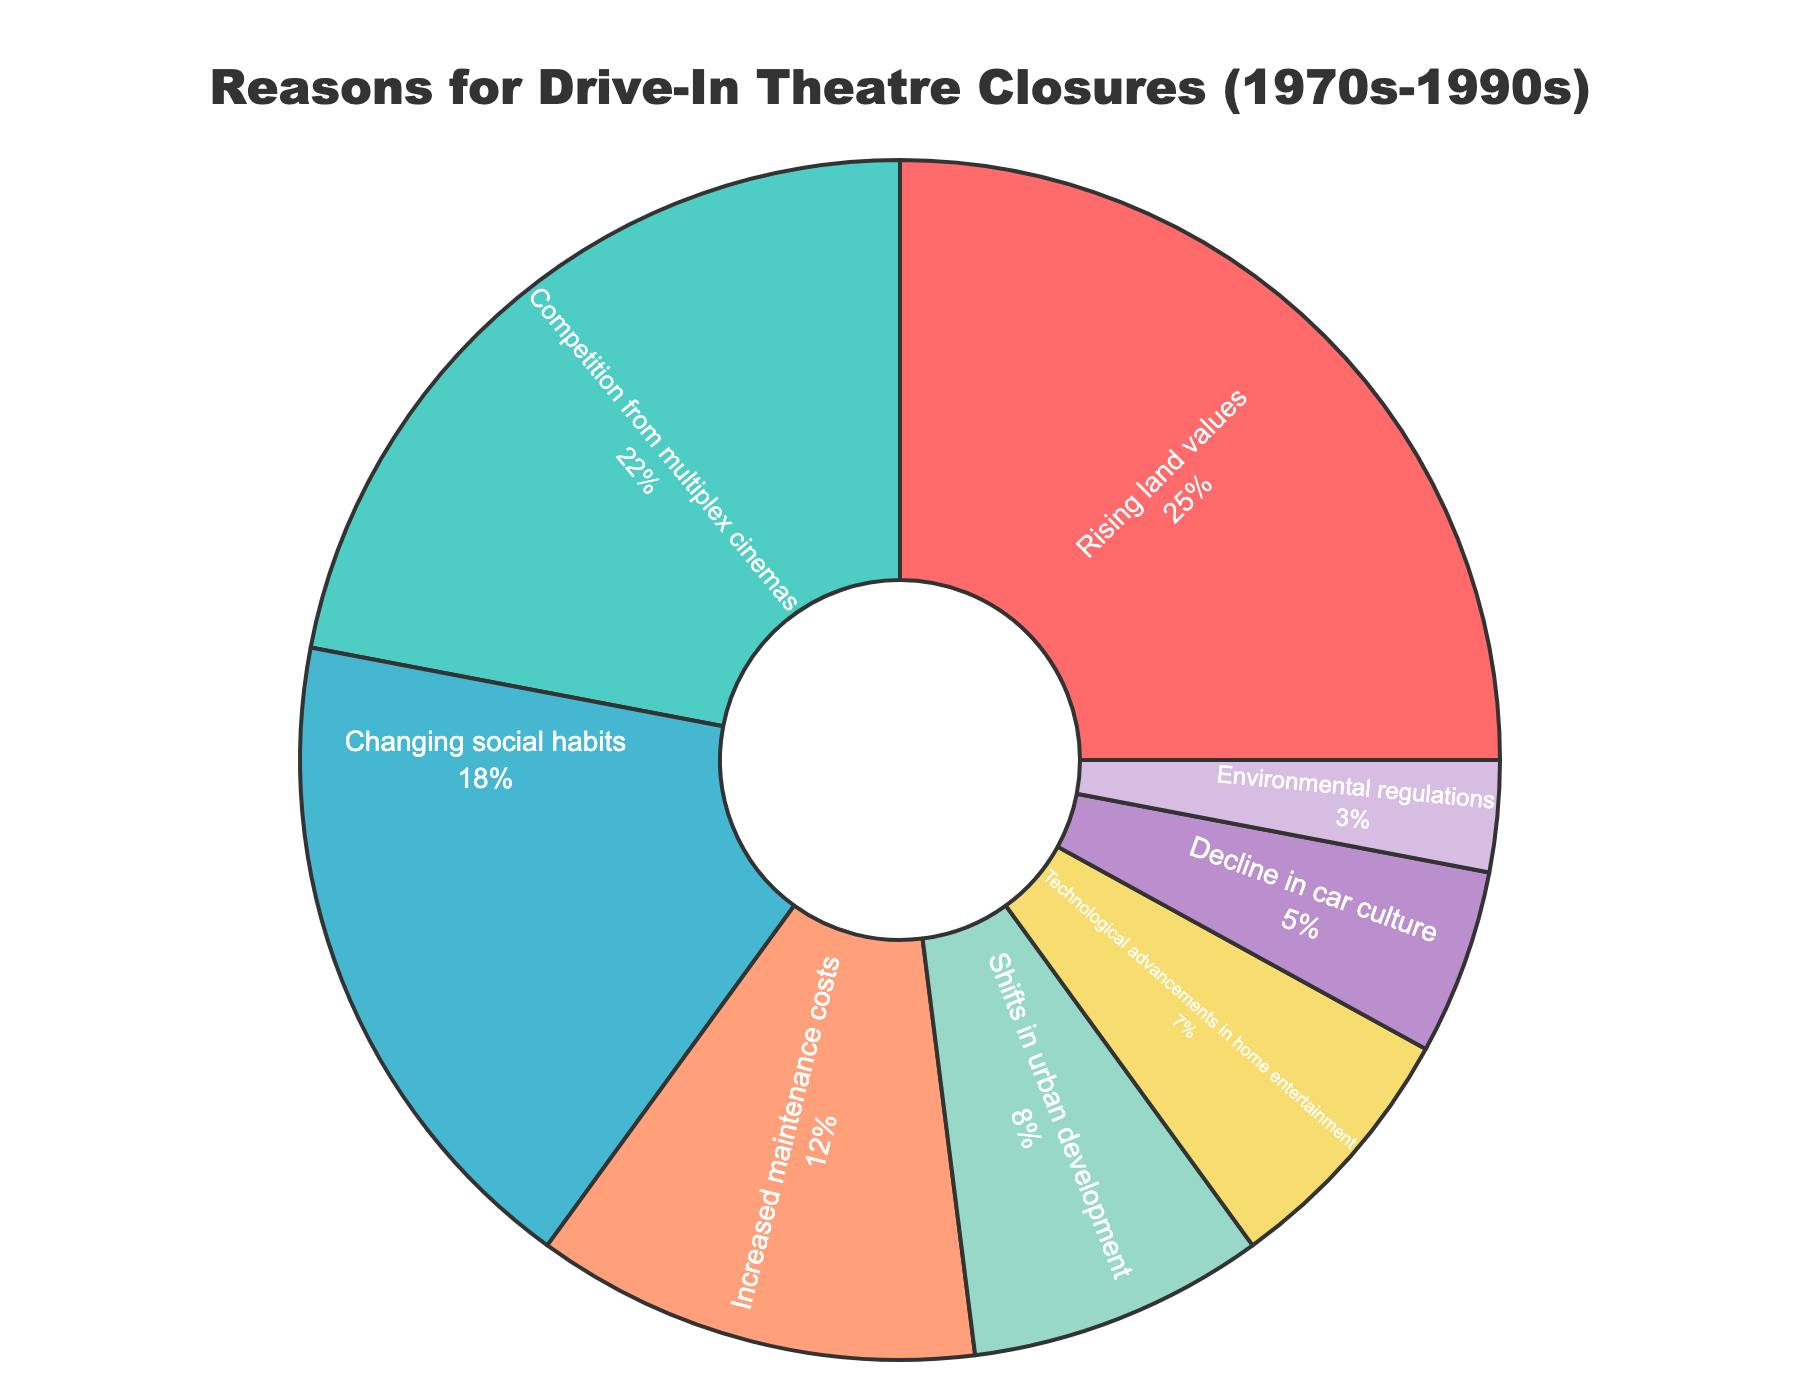What's the most common reason for the drive-in theatre closures? The pie chart shows various reasons with percentages for each. The largest section represents "Rising land values" which occupies 25% of the chart.
Answer: Rising land values Which reason has the second highest percentage for drive-in theatre closures? After identifying the largest section, the next largest section on the pie chart is "Competition from multiplex cinemas" which represents 22%.
Answer: Competition from multiplex cinemas Which two reasons combined make up less than 10% of the closures? The smallest values on the pie chart are "Environmental regulations" at 3% and "Decline in car culture" at 5%. Their sum is 3% + 5% = 8%, which is less than 10%.
Answer: Environmental regulations and Decline in car culture How many reasons contribute to more than 20% of the closures? To determine the number of reasons contributing more than 20%, examine the percentages. "Rising land values" at 25% and "Competition from multiplex cinemas" at 22% are the only ones above 20%. So, there are 2 reasons.
Answer: 2 What percentage of closures is attributed to both "Shifts in urban development" and "Technological advancements in home entertainment"? Look at the percentages for each: "Shifts in urban development" is 8% and "Technological advancements in home entertainment" is 7%. Adding them together gives 8% + 7% = 15%.
Answer: 15% Is the percentage representing "Increased maintenance costs" greater than "Environmental regulations" and "Decline in car culture" combined? "Increased maintenance costs" is 12%. Combine "Environmental regulations" at 3% and "Decline in car culture" at 5%; their sum is 3% + 5% = 8%. Since 12% is greater than 8%, the statement is true.
Answer: Yes Which segments of the pie chart are depicted in shades of green? Visually identify the colors of the segments. "Competition from multiplex cinemas" and "Shifts in urban development" appear in shades of green.
Answer: Competition from multiplex cinemas and Shifts in urban development Is "Changing social habits" a more significant reason for closures than "Increased maintenance costs"? Compare the percentages directly: "Changing social habits" is 18%, while "Increased maintenance costs" is 12%. 18% is greater than 12%, thus "Changing social habits" is a more significant reason.
Answer: Yes What is the difference in percentage between "Rising land values" and "Shifts in urban development"? "Rising land values" is 25% and "Shifts in urban development" is 8%. The difference is 25% - 8% = 17%.
Answer: 17% What portion of the pie chart is dedicated to reasons related to economic factors? Consider "Rising land values" (25%), "Increased maintenance costs" (12%), and "Competition from multiplex cinemas" (22%). Their sum is 25% + 12% + 22% = 59%.
Answer: 59% 